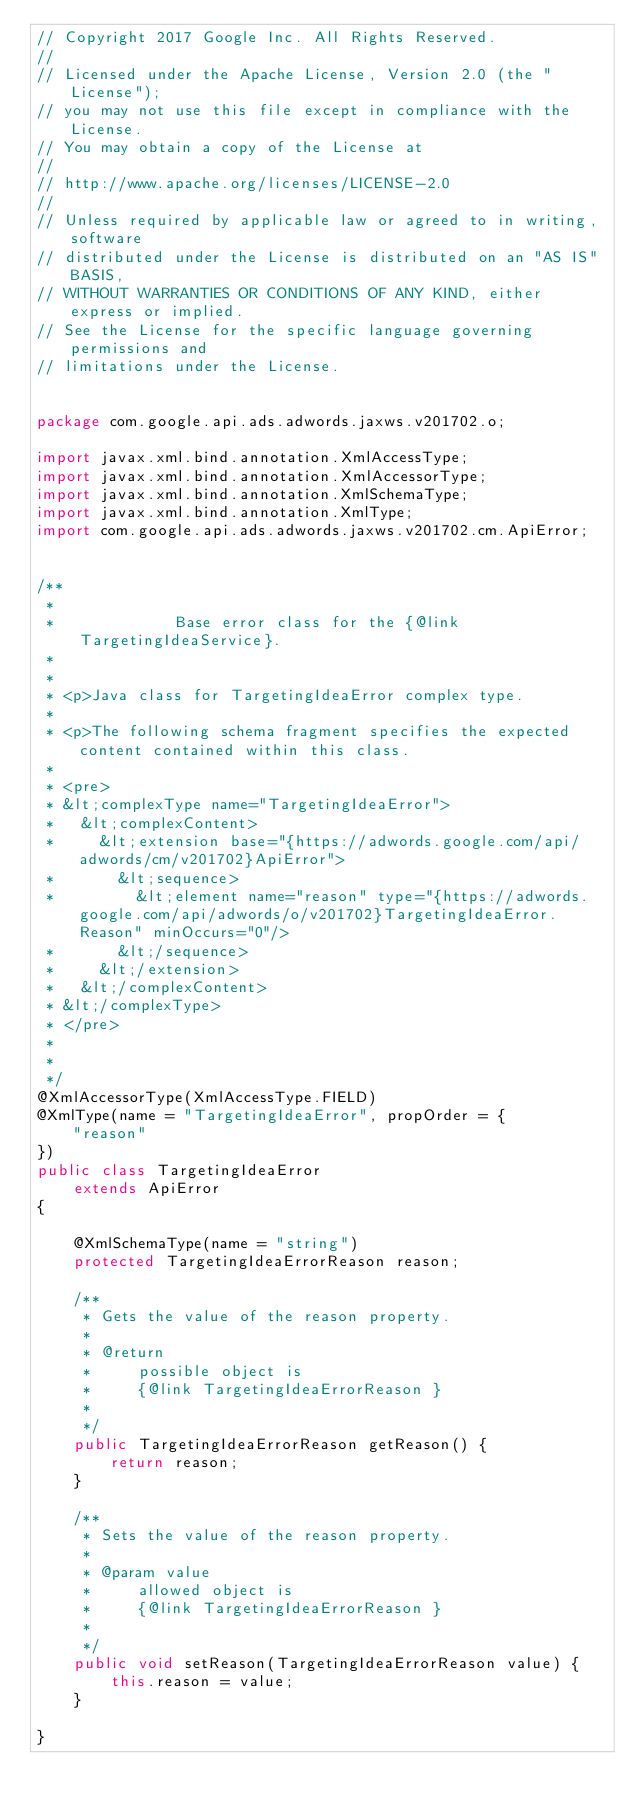<code> <loc_0><loc_0><loc_500><loc_500><_Java_>// Copyright 2017 Google Inc. All Rights Reserved.
//
// Licensed under the Apache License, Version 2.0 (the "License");
// you may not use this file except in compliance with the License.
// You may obtain a copy of the License at
//
// http://www.apache.org/licenses/LICENSE-2.0
//
// Unless required by applicable law or agreed to in writing, software
// distributed under the License is distributed on an "AS IS" BASIS,
// WITHOUT WARRANTIES OR CONDITIONS OF ANY KIND, either express or implied.
// See the License for the specific language governing permissions and
// limitations under the License.


package com.google.api.ads.adwords.jaxws.v201702.o;

import javax.xml.bind.annotation.XmlAccessType;
import javax.xml.bind.annotation.XmlAccessorType;
import javax.xml.bind.annotation.XmlSchemaType;
import javax.xml.bind.annotation.XmlType;
import com.google.api.ads.adwords.jaxws.v201702.cm.ApiError;


/**
 * 
 *             Base error class for the {@link TargetingIdeaService}.
 *           
 * 
 * <p>Java class for TargetingIdeaError complex type.
 * 
 * <p>The following schema fragment specifies the expected content contained within this class.
 * 
 * <pre>
 * &lt;complexType name="TargetingIdeaError">
 *   &lt;complexContent>
 *     &lt;extension base="{https://adwords.google.com/api/adwords/cm/v201702}ApiError">
 *       &lt;sequence>
 *         &lt;element name="reason" type="{https://adwords.google.com/api/adwords/o/v201702}TargetingIdeaError.Reason" minOccurs="0"/>
 *       &lt;/sequence>
 *     &lt;/extension>
 *   &lt;/complexContent>
 * &lt;/complexType>
 * </pre>
 * 
 * 
 */
@XmlAccessorType(XmlAccessType.FIELD)
@XmlType(name = "TargetingIdeaError", propOrder = {
    "reason"
})
public class TargetingIdeaError
    extends ApiError
{

    @XmlSchemaType(name = "string")
    protected TargetingIdeaErrorReason reason;

    /**
     * Gets the value of the reason property.
     * 
     * @return
     *     possible object is
     *     {@link TargetingIdeaErrorReason }
     *     
     */
    public TargetingIdeaErrorReason getReason() {
        return reason;
    }

    /**
     * Sets the value of the reason property.
     * 
     * @param value
     *     allowed object is
     *     {@link TargetingIdeaErrorReason }
     *     
     */
    public void setReason(TargetingIdeaErrorReason value) {
        this.reason = value;
    }

}
</code> 